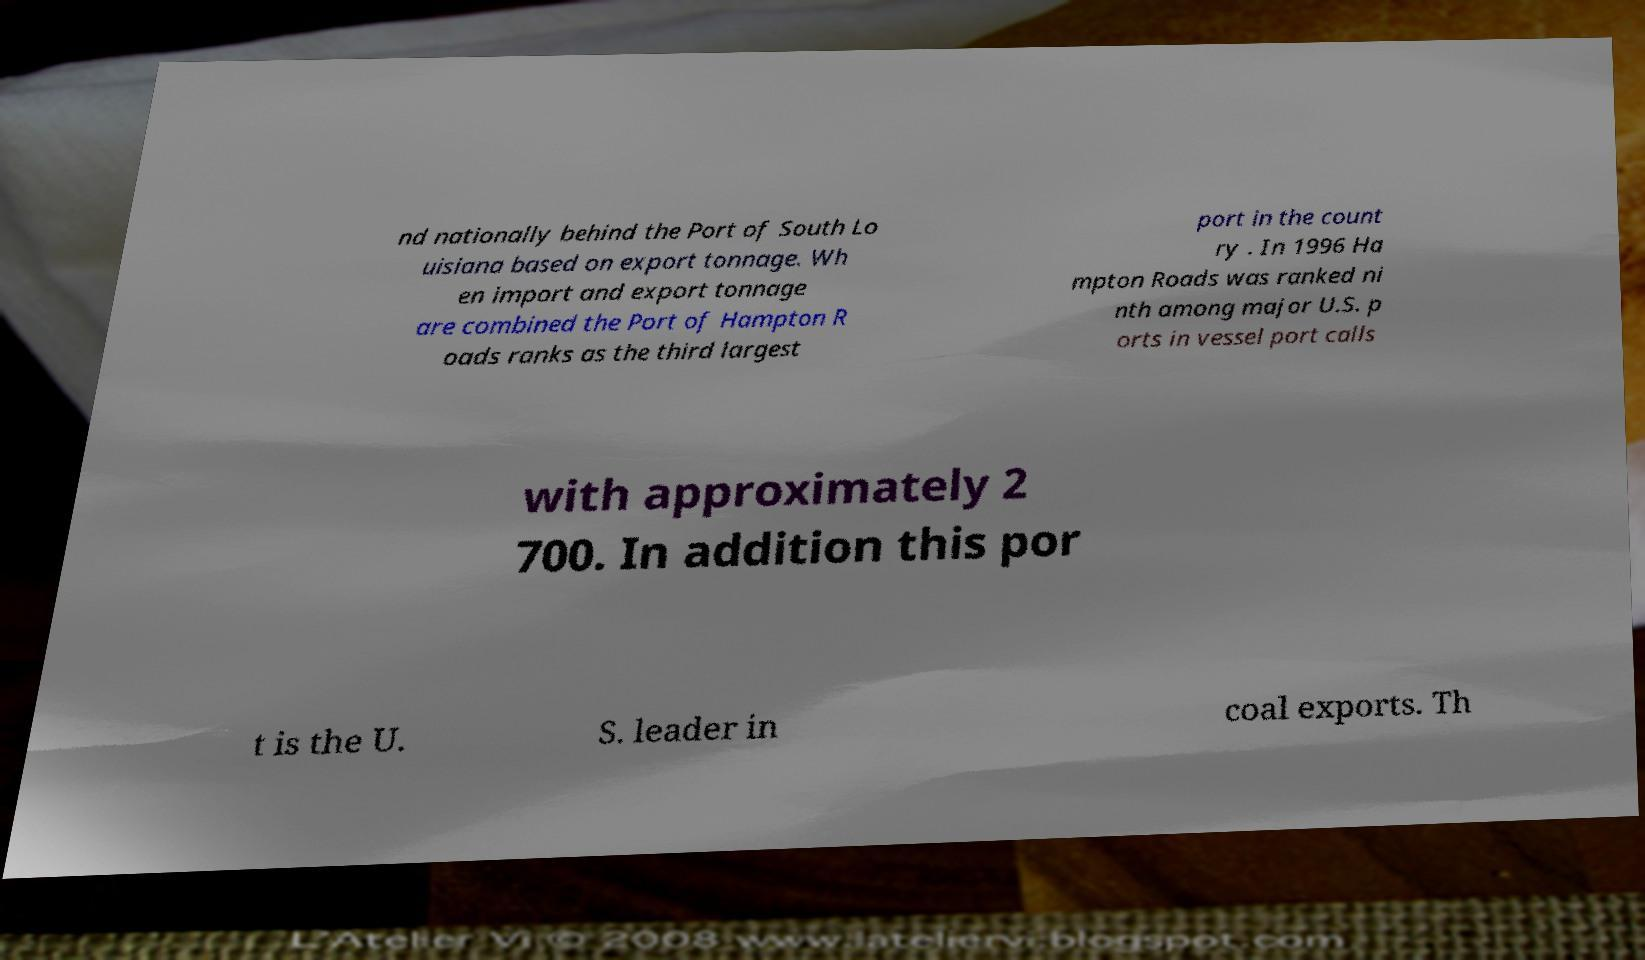What messages or text are displayed in this image? I need them in a readable, typed format. nd nationally behind the Port of South Lo uisiana based on export tonnage. Wh en import and export tonnage are combined the Port of Hampton R oads ranks as the third largest port in the count ry . In 1996 Ha mpton Roads was ranked ni nth among major U.S. p orts in vessel port calls with approximately 2 700. In addition this por t is the U. S. leader in coal exports. Th 